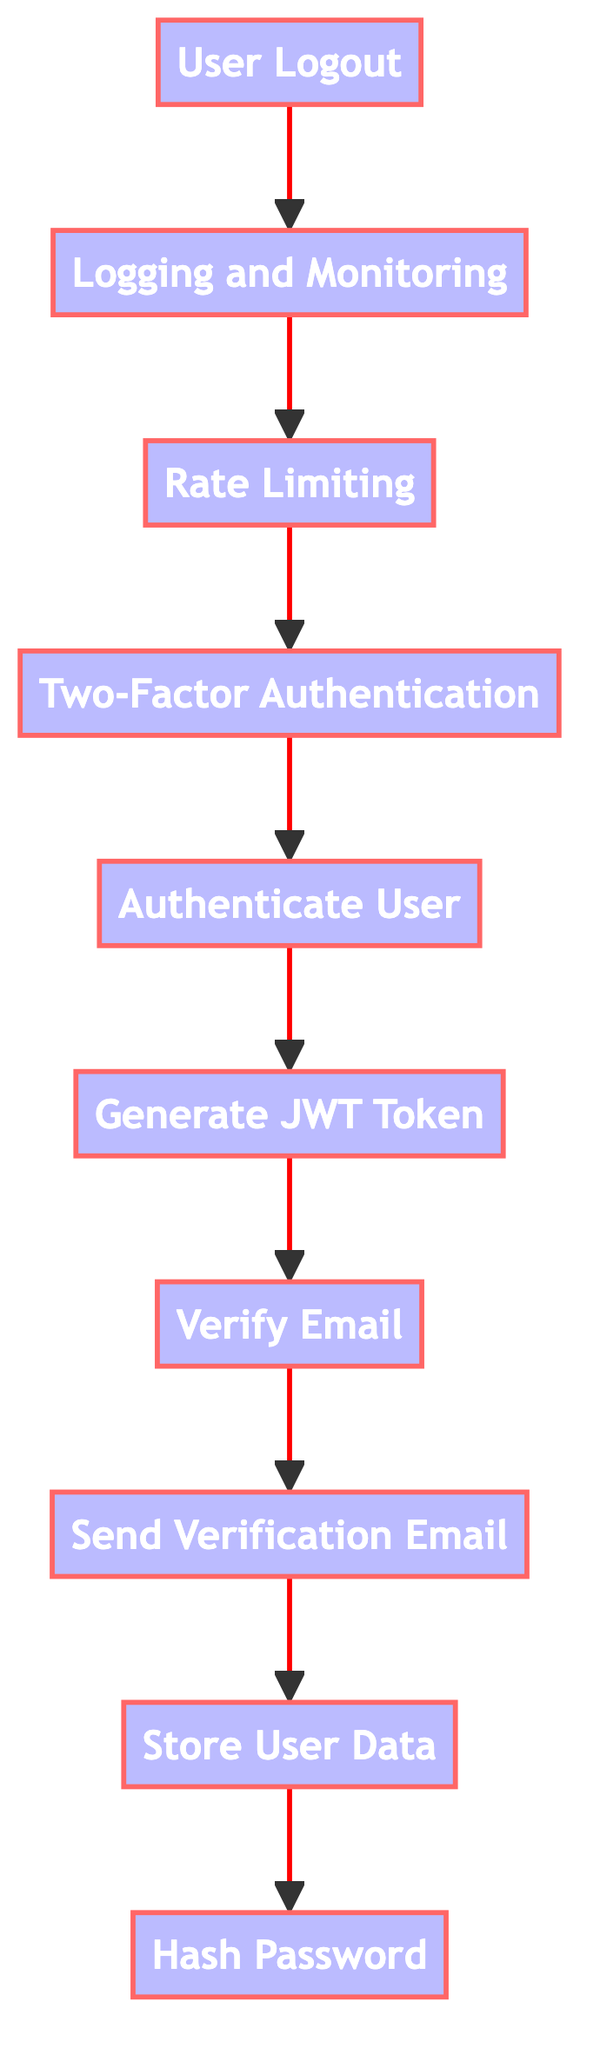What is the first step in the authentication process? The diagram shows that the first step, at the bottom, is "Hash Password." It indicates that hashing the password is the initial action taken when implementing the user authentication process.
Answer: Hash Password How many functions are represented in this flowchart? By counting all the nodes labeled as functions in the diagram, there are ten functions listed, from "Hash Password" up to "User Logout."
Answer: 10 What is the output of the "Authenticate User" function? The "Authenticate User" function feeds directly into the "Generate JWT Token" function, indicating that successful authentication allows for the generation of a token for access.
Answer: Generate JWT Token Which function is executed after the "Send Verification Email" function? Following the flow from the "Send Verification Email" function, the next step is "Store User Data." This implies that after sending the email, the system moves on to store the user's data.
Answer: Store User Data How does the "Two-Factor Authentication" function relate to the "Authenticate User" function? The flow shows that "Two-Factor Authentication" occurs after "Authenticate User." This means that if activated, it adds an additional step for enhanced security after initial user validation.
Answer: After What function is directly before "User Logout"? The diagram clearly shows that "Logging and Monitoring" is the function that comes right before "User Logout," indicating monitoring occurs before user session termination.
Answer: Logging and Monitoring In what order do the last three steps of the authentication process occur? The last three steps, as indicated in the flowchart, are "User Logout," "Logging and Monitoring," and "Rate Limiting." Reversing this order, the sequence is from logging out back to monitoring attempts.
Answer: Logging and Monitoring, Rate Limiting Which functions are involved in the email verification process? The functions "Send Verification Email" and "Verify Email" are involved in the email verification process according to the directional flow in the diagram, indicating these steps are sequential.
Answer: Send Verification Email, Verify Email What happens if an additional verification is required during login? If additional verification is activated, the flow indicates that "Two-Factor Authentication" takes place after "Authenticate User," ensuring that extra security measures follow the credential validation.
Answer: Two-Factor Authentication 